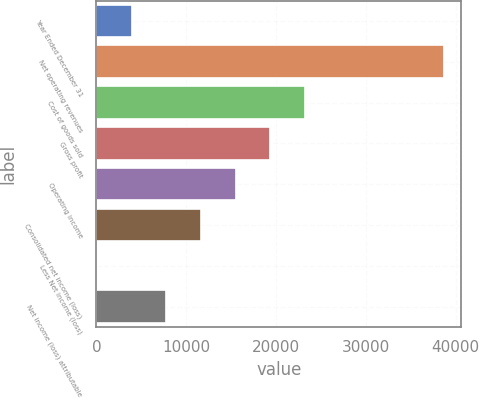Convert chart. <chart><loc_0><loc_0><loc_500><loc_500><bar_chart><fcel>Year Ended December 31<fcel>Net operating revenues<fcel>Cost of goods sold<fcel>Gross profit<fcel>Operating income<fcel>Consolidated net income (loss)<fcel>Less Net income (loss)<fcel>Net income (loss) attributable<nl><fcel>3946.4<fcel>38663<fcel>23233.4<fcel>19376<fcel>15518.6<fcel>11661.2<fcel>89<fcel>7803.8<nl></chart> 